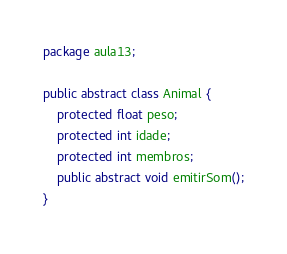Convert code to text. <code><loc_0><loc_0><loc_500><loc_500><_Java_>package aula13;

public abstract class Animal {
    protected float peso;
    protected int idade;
    protected int membros;
    public abstract void emitirSom();
}
</code> 